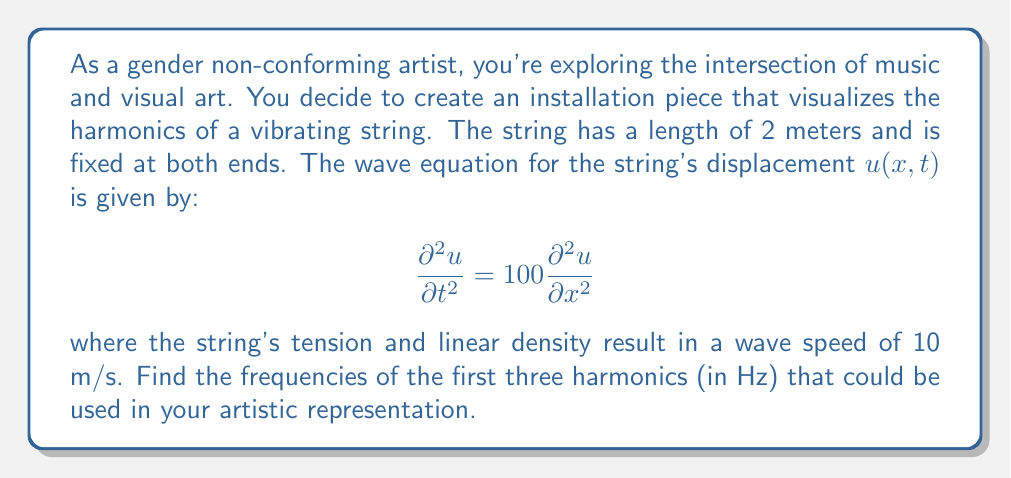Show me your answer to this math problem. To solve this problem, we'll follow these steps:

1) The general solution for the wave equation with fixed ends is:

   $$u(x,t) = \sum_{n=1}^{\infty} A_n \sin(\frac{n\pi x}{L}) \cos(\frac{n\pi c t}{L})$$

   where $L$ is the length of the string and $c$ is the wave speed.

2) From the given equation, we can see that $c^2 = 100$, so $c = 10$ m/s.

3) The frequency of the nth harmonic is given by:

   $$f_n = \frac{nc}{2L}$$

4) We're given that $L = 2$ m and $c = 10$ m/s. Let's substitute these values:

   $$f_n = \frac{n(10)}{2(2)} = \frac{5n}{2}$$

5) Now, let's calculate the first three harmonics:

   For n = 1 (fundamental frequency):
   $$f_1 = \frac{5(1)}{2} = 2.5 \text{ Hz}$$

   For n = 2 (first overtone):
   $$f_2 = \frac{5(2)}{2} = 5 \text{ Hz}$$

   For n = 3 (second overtone):
   $$f_3 = \frac{5(3)}{2} = 7.5 \text{ Hz}$$

These frequencies represent the vibration rates that will produce visually distinct patterns in your artistic installation.
Answer: The frequencies of the first three harmonics are:
1st harmonic (fundamental): 2.5 Hz
2nd harmonic (1st overtone): 5 Hz
3rd harmonic (2nd overtone): 7.5 Hz 